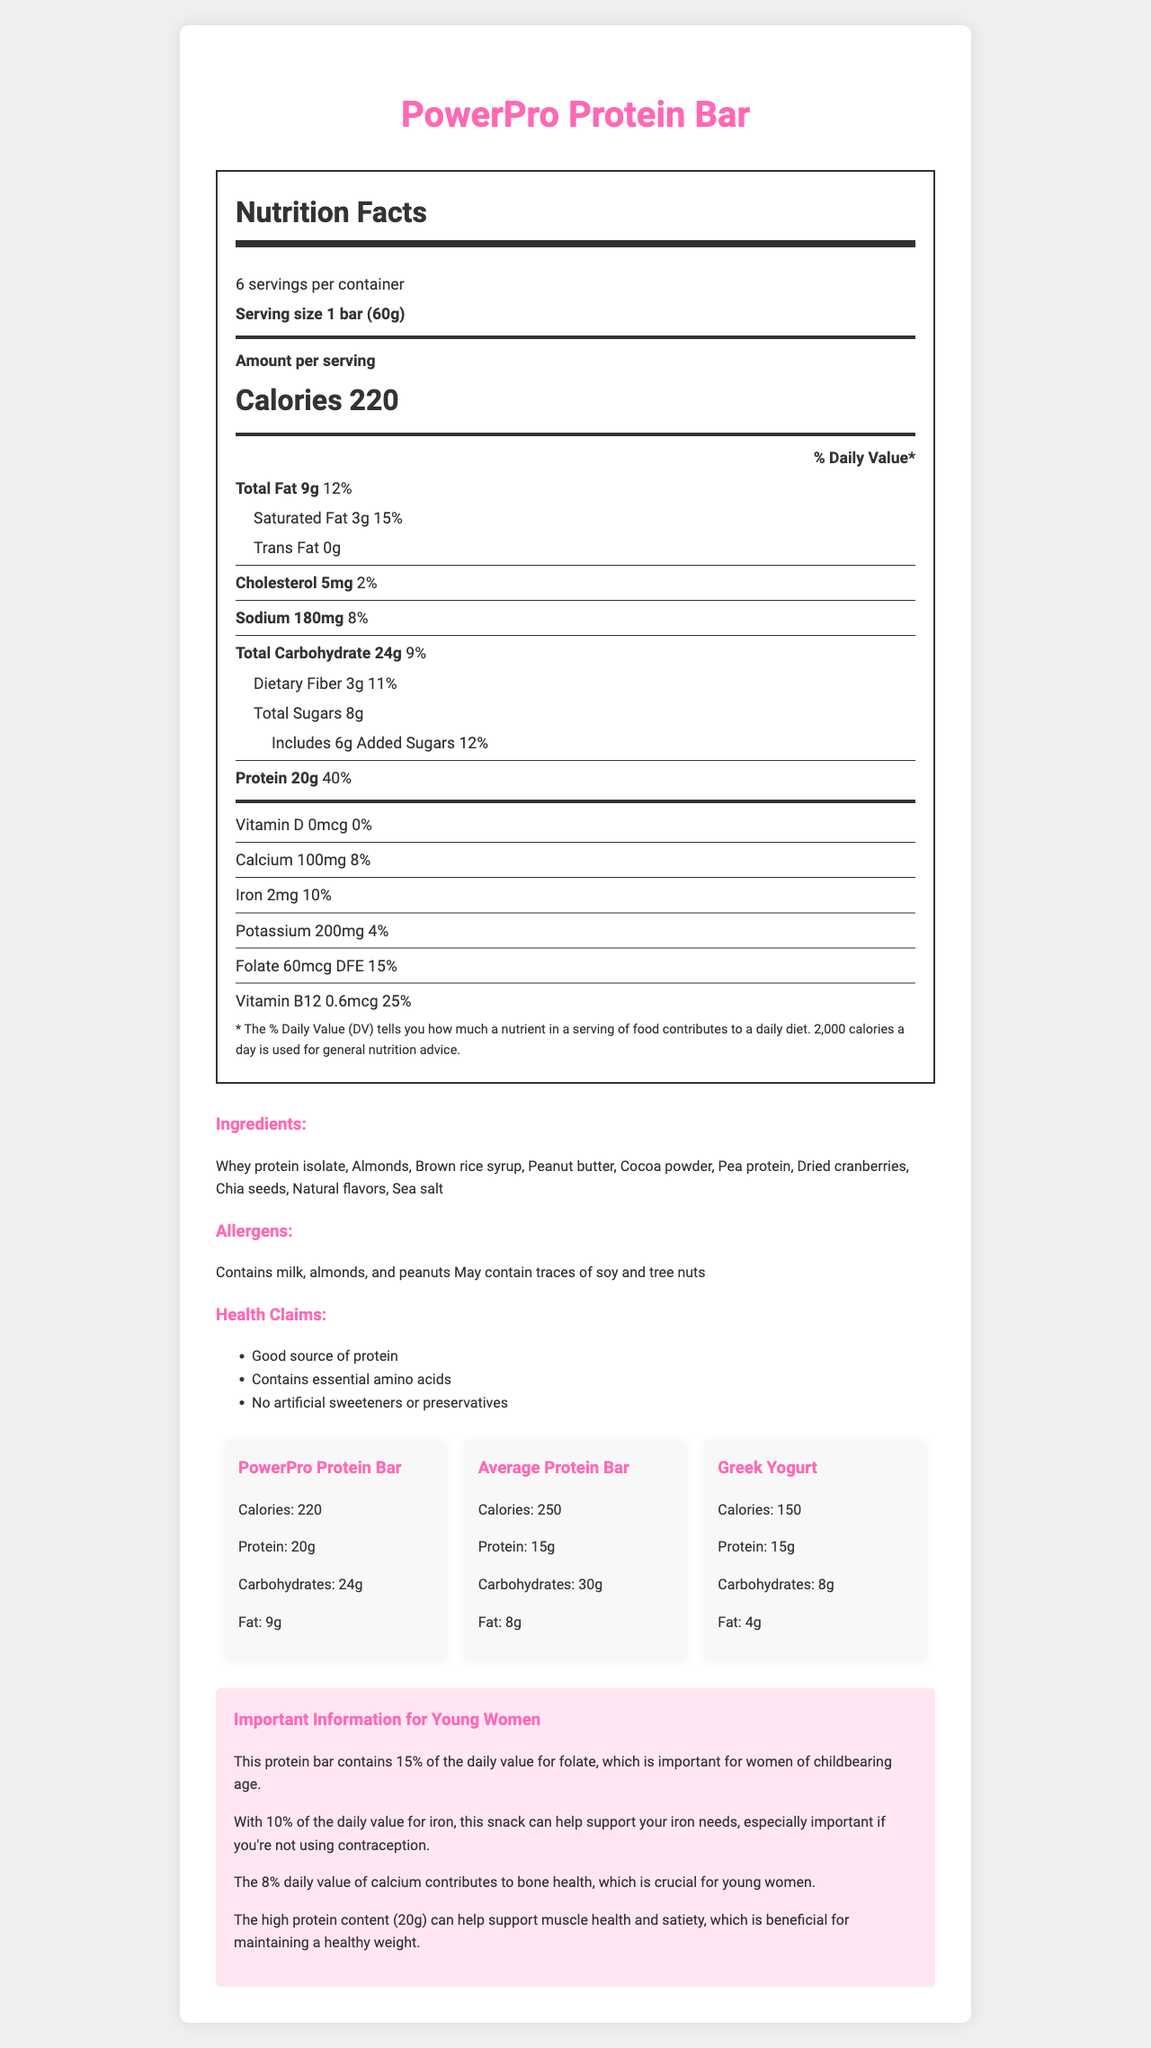what is the serving size of the PowerPro Protein Bar? The serving size is specifically mentioned in the nutrition label under "Serving size."
Answer: 1 bar (60g) how many calories are in one serving of the PowerPro Protein Bar? The calories per serving are prominently displayed in the "Amount per serving" section of the nutrition label.
Answer: 220 what percentage of the daily value is the protein content in PowerPro Protein Bar? The protein content and its daily value percentage is listed in the nutrition facts, showing 20g and 40%, respectively.
Answer: 40% list the allergens present in the PowerPro Protein Bar The allergens are clearly stated in the ingredients section under "Allergens."
Answer: Contains milk, almonds, and peanuts; May contain traces of soy and tree nuts how much iron is in a serving of the PowerPro Protein Bar? The iron content is specified in the nutrition facts with its amount and daily value percentage.
Answer: 2mg which of these has the highest protein content? A. PowerPro Protein Bar B. Average Protein Bar C. Greek Yogurt D. Hard-Boiled Eggs The PowerPro Protein Bar has 20g of protein, which is higher compared to the 15g in both the average protein bar and Greek yogurt, and 12g in hard-boiled eggs.
Answer: A. PowerPro Protein Bar what is the daily value percentage of saturated fat in the PowerPro Protein Bar? The daily value percentage for saturated fat is indicated in the nutrition facts as 15%.
Answer: 15% which snack has the lowest calorie content? A. PowerPro Protein Bar B. Average Protein Bar C. Greek Yogurt D. Hard-Boiled Eggs Hard-boiled eggs have 140 calories, which is lower than the PowerPro Protein Bar (220 calories), the average protein bar (250 calories), and Greek yogurt (150 calories).
Answer: D. Hard-Boiled Eggs is there any trans fat in the PowerPro Protein Bar? The nutrition label explicitly states that there is 0g of trans fat.
Answer: No can the document tell you if PowerPro Protein Bar is gluten-free? The document does not provide information about the gluten content of the PowerPro Protein Bar.
Answer: Not enough information how does the carbohydrate content of PowerPro Protein Bar compare to Greek Yogurt? The PowerPro Protein Bar has 24g of carbohydrates, whereas Greek yogurt has 8g.
Answer: PowerPro Protein Bar has more carbohydrates summarize the main nutritional benefits of the PowerPro Protein Bar for a young woman not using contraception. The document highlights nutritional aspects such as high protein, essential minerals like iron and calcium, and the importance of folate for women of childbearing age.
Answer: The PowerPro Protein Bar provides significant amounts of protein (20g, 40% DV), iron (10% DV), calcium (8% DV), and folate (15% DV), all of which are beneficial for muscle health, satiety, iron needs, bone health, and folic acid intake. explain the importance of folate in the PowerPro Protein Bar for young women. The document specifies that folate is crucial for women of childbearing age, and the protein bar provides 60mcg DFE, covering 15% of the daily requirement.
Answer: Folate in the PowerPro Protein Bar helps meet 15% of the daily value, which is important for women of childbearing age. 